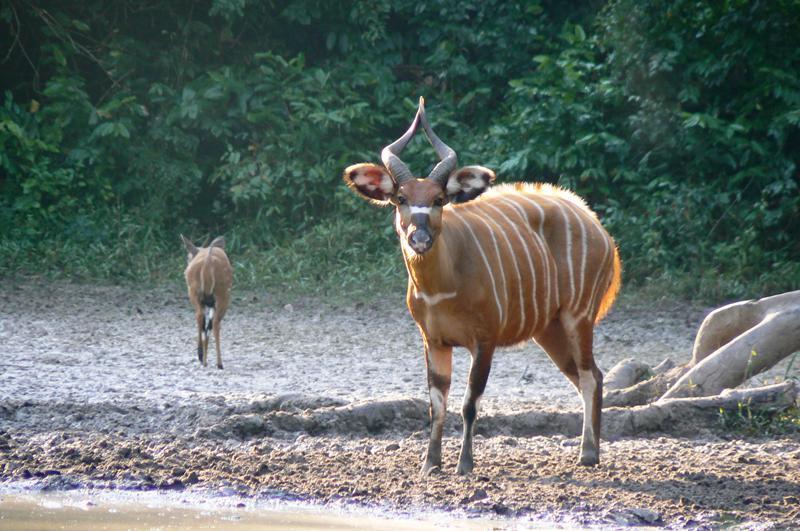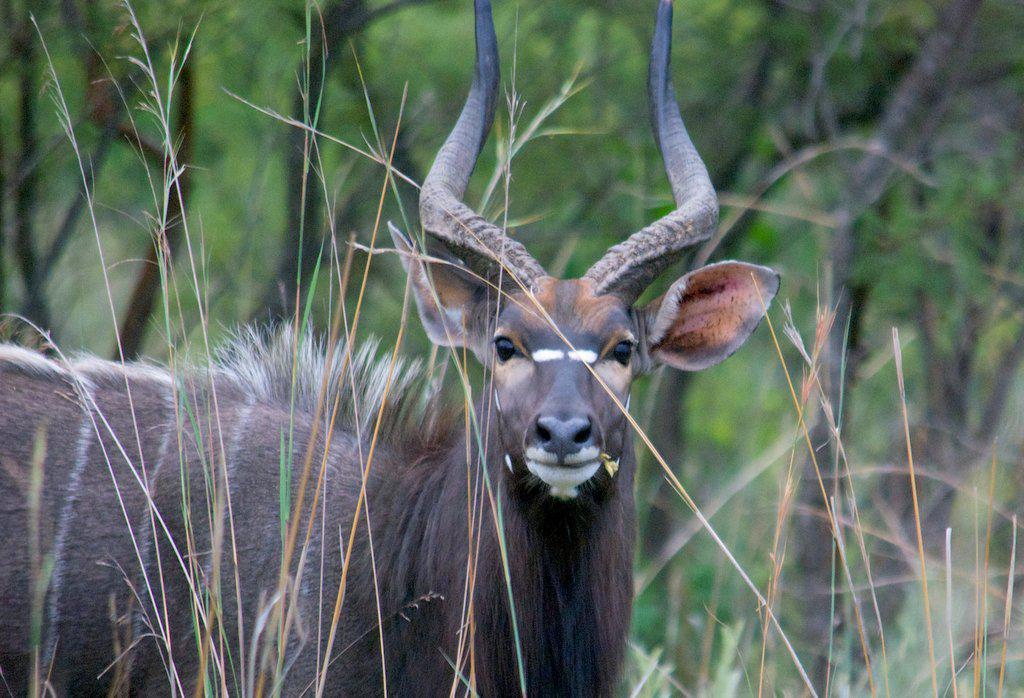The first image is the image on the left, the second image is the image on the right. Given the left and right images, does the statement "You can see a second animal further off in the background." hold true? Answer yes or no. Yes. The first image is the image on the left, the second image is the image on the right. Given the left and right images, does the statement "There is a total of 1 gazelle laying on the ground." hold true? Answer yes or no. No. 